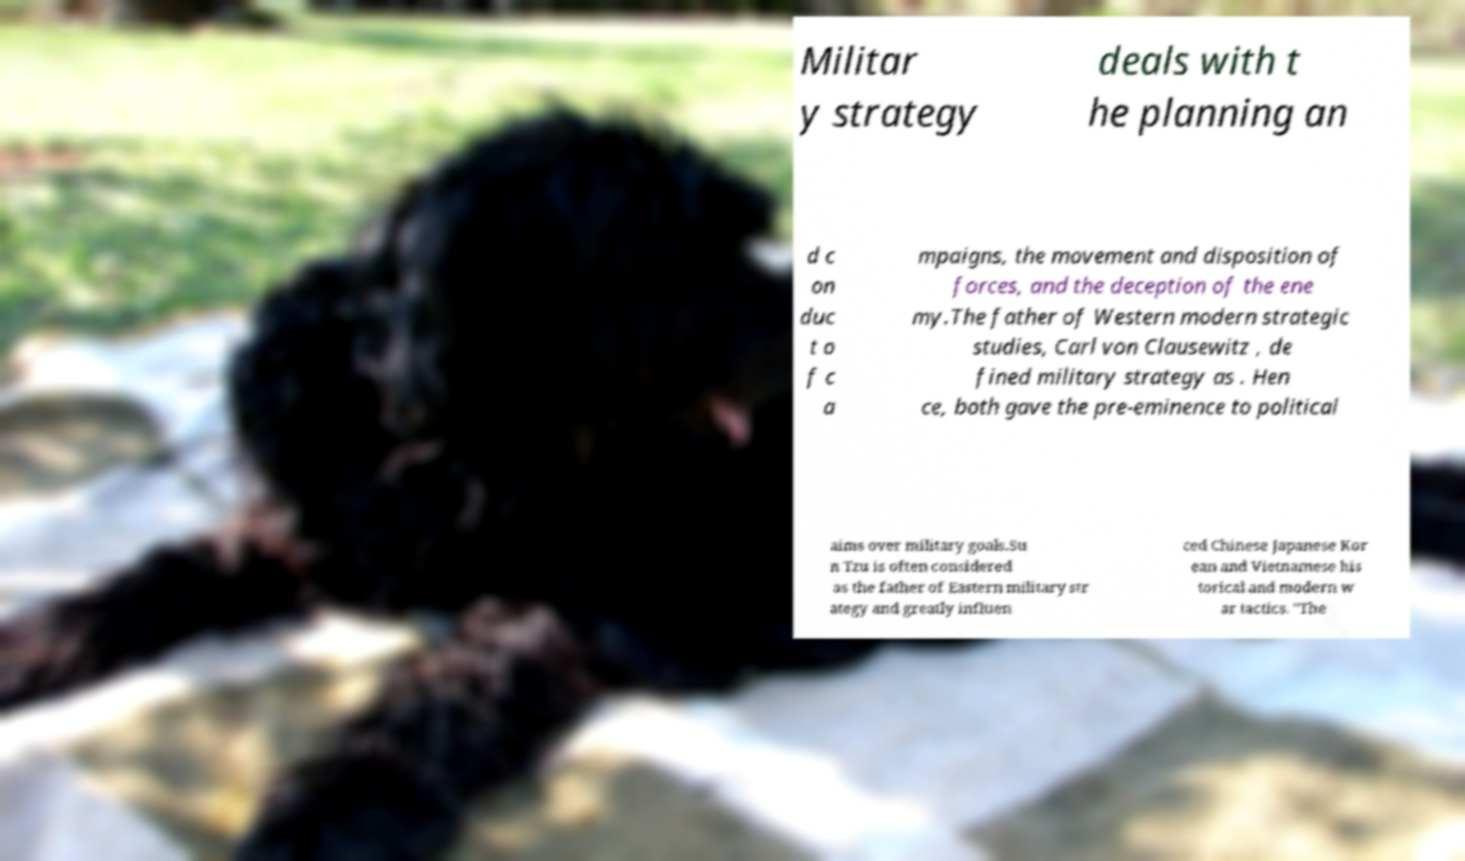Can you accurately transcribe the text from the provided image for me? Militar y strategy deals with t he planning an d c on duc t o f c a mpaigns, the movement and disposition of forces, and the deception of the ene my.The father of Western modern strategic studies, Carl von Clausewitz , de fined military strategy as . Hen ce, both gave the pre-eminence to political aims over military goals.Su n Tzu is often considered as the father of Eastern military str ategy and greatly influen ced Chinese Japanese Kor ean and Vietnamese his torical and modern w ar tactics. "The 